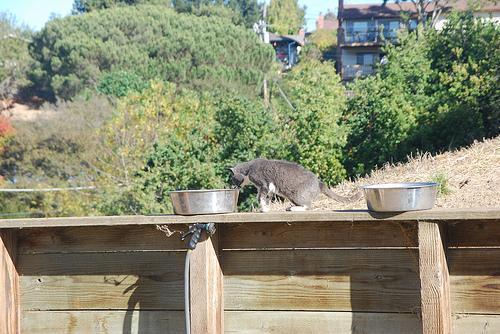How many cats are there?
Give a very brief answer. 1. 